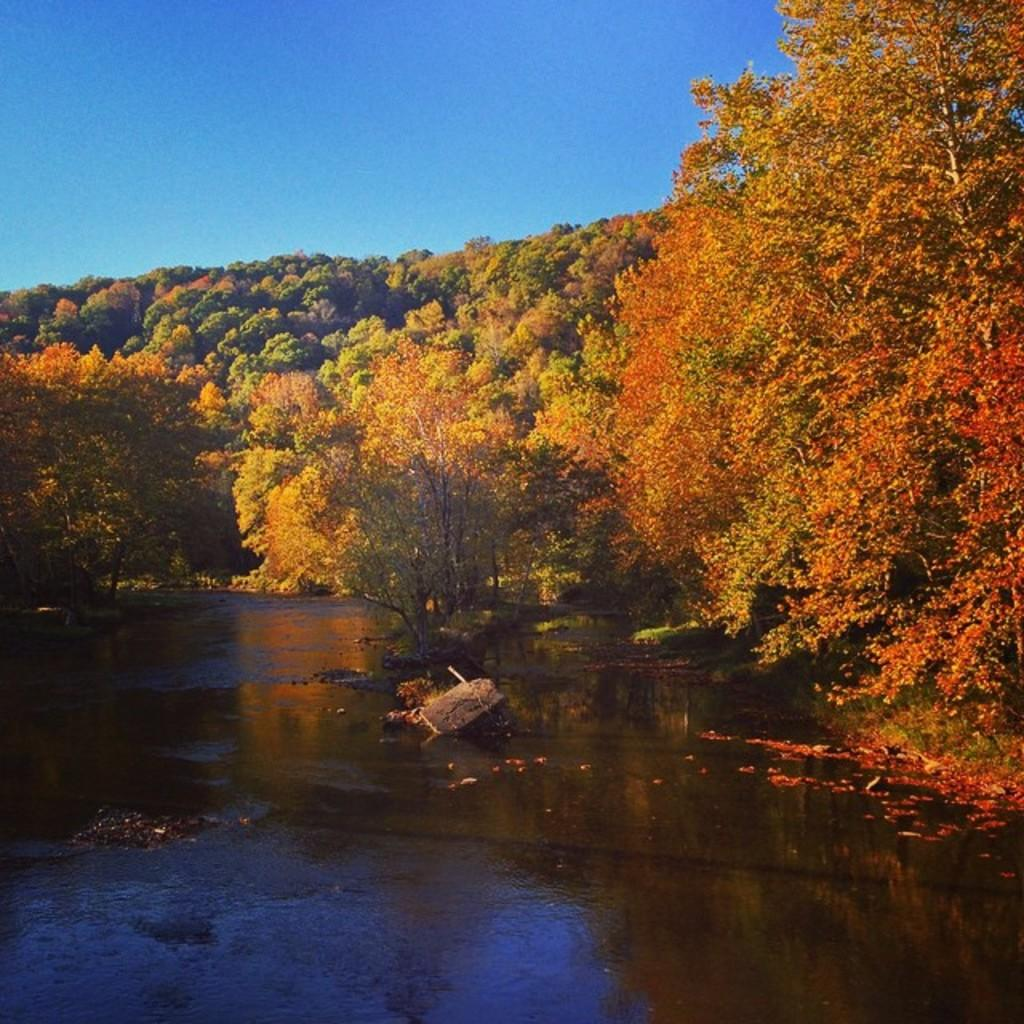What type of vegetation can be seen in the image? There are trees in the image. What colors are the trees displaying? The trees have green, yellow, and orange colors. What natural element is visible in the image besides the trees? There is water visible in the image. What is the color of the sky in the image? The sky is blue in color. How many books are stacked on the kitten in the image? There is no kitten or books present in the image. 